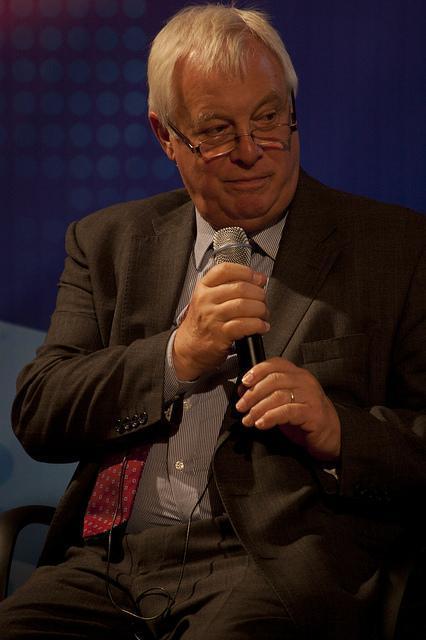How many hands are in the photo?
Give a very brief answer. 2. 